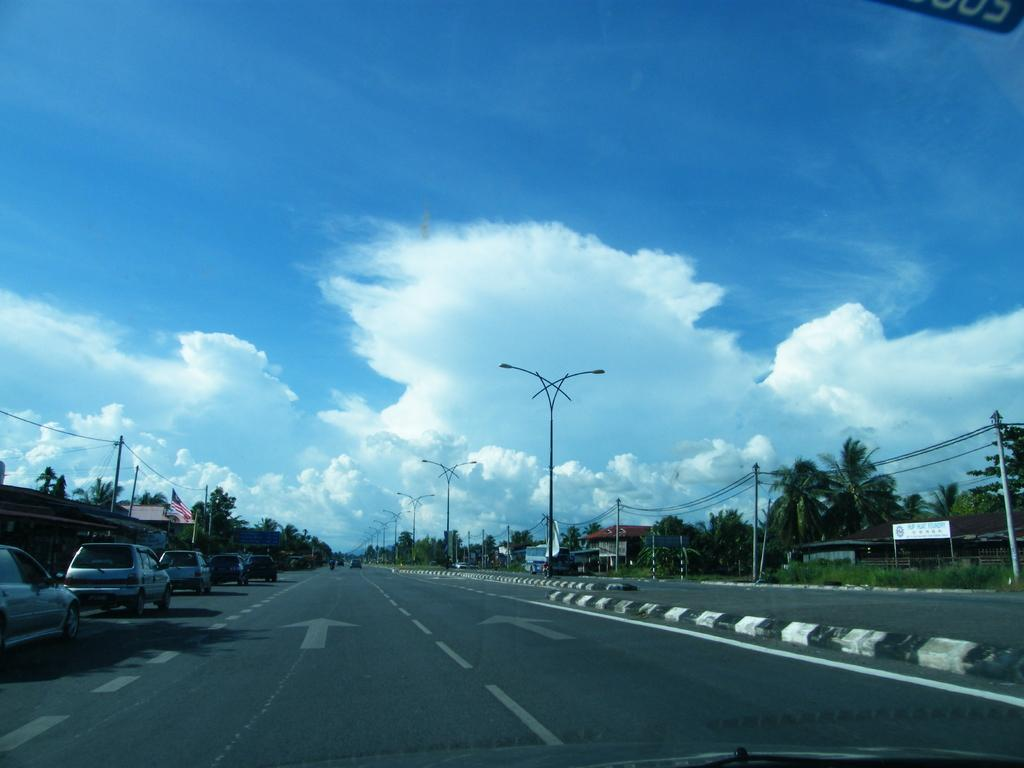What can be seen parked on the road in the image? There are cars parked on the road in the image. What else is present in the image besides the parked cars? There are poles and trees in the image. How many balls are being juggled by the rat in the image? There is no rat or balls present in the image. 